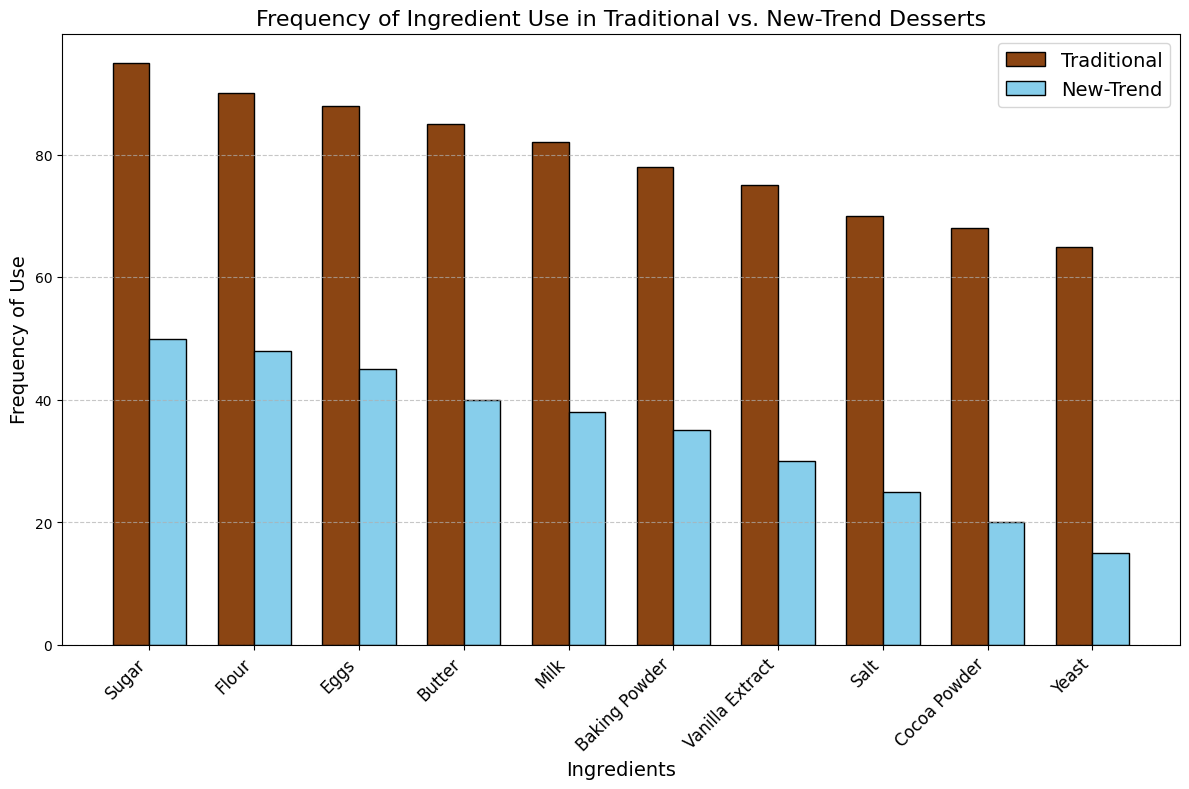what ingredient has the highest frequency of use in traditional desserts? The highest bar in the traditional desserts group represents the ingredient used most frequently. By visually inspecting the plot, the tallest bar corresponds to 'Sugar' at a height of 95.
Answer: Sugar Which ingredient is used more frequently in new-trend desserts than traditional ones? By comparing the heights of the bars, 'Rice Flour', 'Coconut Oil', 'Almond Milk', 'Stevia', and 'Agar Agar' are only present in new-trend desserts, indicating higher usage in comparison to traditional desserts, which do not include these ingredients.
Answer: Rice Flour, Coconut Oil, Almond Milk, Stevia, Agar Agar What is the difference in the frequency of use of eggs between traditional and new-trend desserts? Locate the bars for 'Eggs' in both traditional and new-trend groups. The frequency for traditional is 88, and for new-trend it is 45. Subtract the new-trend value from the traditional value (88 - 45).
Answer: 43 Which five ingredients have the highest frequency in traditional desserts? Visually inspect the heights of the bars in the traditional desserts group. The five highest bars correspond to 'Sugar', 'Flour', 'Eggs', 'Butter', and 'Milk'.
Answer: Sugar, Flour, Eggs, Butter, Milk What is the average frequency of the top three ingredients in new-trend desserts? Identify the top three ingredients by the height of the bars in new-trend desserts: 'Sugar', 'Flour', and 'Eggs' with frequencies 50, 48, and 45, respectively. Calculate the average (50 + 48 + 45) / 3.
Answer: 47.67 Which ingredient has the lowest frequency in traditional desserts, and what is its frequency? Locate the shortest bar in the traditional group which corresponds to 'Yeast' with a frequency of 65.
Answer: Yeast, 65 What is the total frequency of use for ingredients starting with the letter 'B' in both dessert types? Identify the ingredients starting with 'B': 'Butter' and 'Baking Powder'. 'Butter' frequency is 85 (traditional) + 40 (new-trend) = 125. 'Baking Powder' is 78 (traditional) + 0 (new-trend) = 78. Sum them up (125 + 78).
Answer: 203 How much more frequently is cocoa powder used in traditional desserts compared to new-trend desserts? Locate the bars for 'Cocoa Powder'. Traditional has a frequency of 68, and new-trend does not list 'Cocoa Powder'. Thus, the difference is 68 - 0.
Answer: 68 What proportion of the total frequency of 'Milk' use occurs in traditional desserts? Sum the 'Milk' frequencies for both dessert types: 82 (traditional) + 38 (new-trend) = 120. The proportion from traditional is 82/120.
Answer: 0.683 Do more traditional or new-trend desserts use vanilla extract? Look at the bars for 'Vanilla Extract'. Traditional lists 75, while new-trend does not include it, making the value effectively 0 for new-trend desserts.
Answer: Traditional 